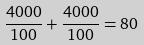Convert formula to latex. <formula><loc_0><loc_0><loc_500><loc_500>\frac { 4 0 0 0 } { 1 0 0 } + \frac { 4 0 0 0 } { 1 0 0 } = 8 0</formula> 